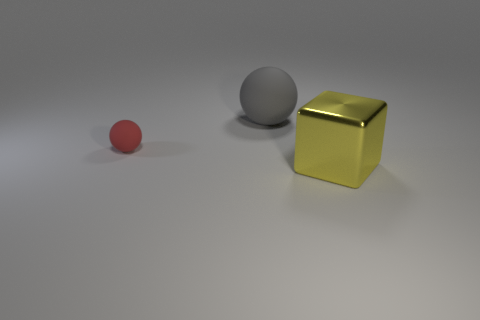What material is the yellow cube that is the same size as the gray rubber sphere?
Give a very brief answer. Metal. How big is the thing that is to the right of the small red object and in front of the large gray thing?
Offer a very short reply. Large. Does the small red sphere have the same material as the big object in front of the tiny thing?
Keep it short and to the point. No. What number of things are either things that are to the right of the big matte ball or brown shiny spheres?
Offer a very short reply. 1. There is a object that is both right of the small thing and on the left side of the big shiny block; what is its shape?
Offer a terse response. Sphere. Are there any other things that are the same size as the red thing?
Ensure brevity in your answer.  No. What size is the gray object that is made of the same material as the tiny red thing?
Your response must be concise. Large. What number of objects are large objects that are behind the metallic cube or large things that are left of the yellow shiny cube?
Give a very brief answer. 1. There is a rubber ball to the right of the red object; is its size the same as the big metallic object?
Ensure brevity in your answer.  Yes. There is a thing behind the red rubber sphere; what color is it?
Your answer should be very brief. Gray. 